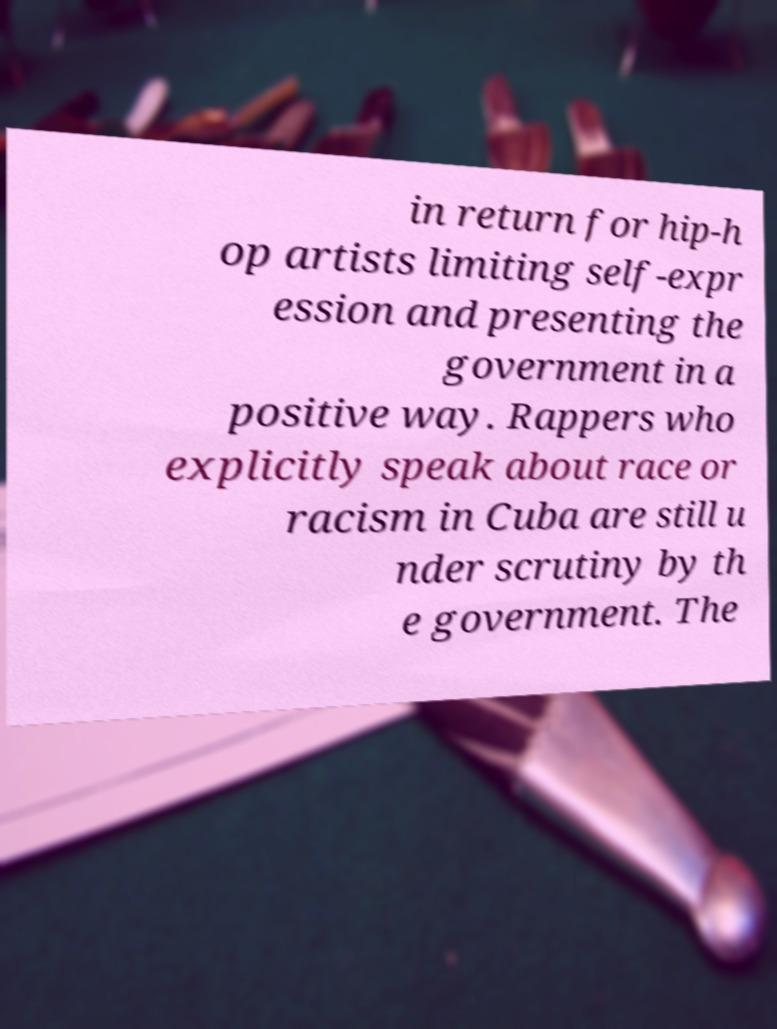Can you read and provide the text displayed in the image?This photo seems to have some interesting text. Can you extract and type it out for me? in return for hip-h op artists limiting self-expr ession and presenting the government in a positive way. Rappers who explicitly speak about race or racism in Cuba are still u nder scrutiny by th e government. The 